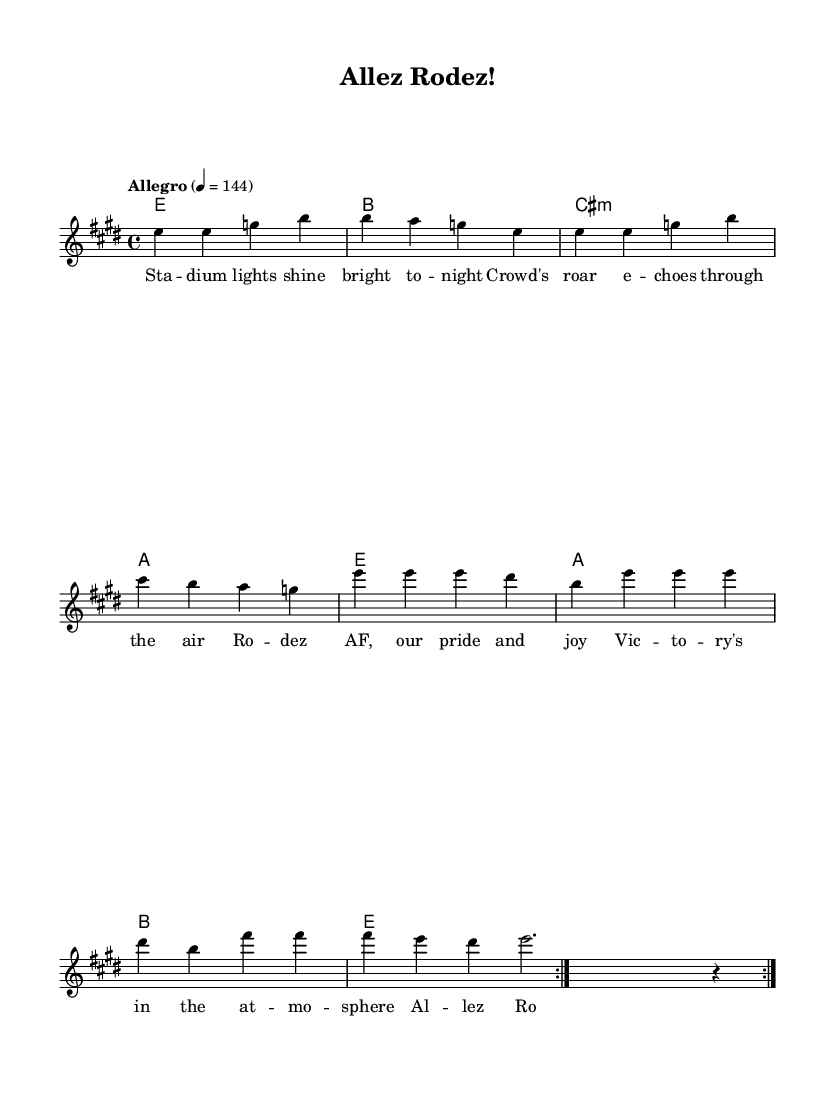What is the key signature of this music? The key signature indicates the key of E major, which has four sharps: F#, C#, G#, and D#. This is confirmed by the `\key e \major` directive present in the code.
Answer: E major What is the time signature of this music? The time signature is represented as 4/4, which means there are four beats in a measure and the quarter note receives one beat. This is directly stated in the code as `\time 4/4`.
Answer: 4/4 What is the tempo marking for this music? The tempo marking shows that the piece should be played at an Allegro speed, specifically indicating 144 beats per minute. This is indicated in the code with `\tempo "Allegro" 4 = 144`.
Answer: Allegro How many measures are in the melody section repeated? The melody section is marked to repeat two times as indicated by the `\repeat volta 2` notation surrounding the melody notes, which signifies the repetition of the measures within its scope.
Answer: 2 What is the title of the song? The title of the song is displayed in the header section of the code as `title = "Allez Rodez!"`, which signifies its identity.
Answer: Allez Rodez! What is the main theme of the lyrics? The lyrics focus on the experience and emotion surrounding a football match, specifically celebrating the team Rodez AF and the atmosphere of victory during matches. This is derived from the content of the provided lyrics.
Answer: Football pride How many chord changes occur in one complete cycle of the harmonies? There are four chord changes in one complete cycle of the harmonies as evident from the harmonic structure provided in the code, where each line specifies a chord for the harmony.
Answer: 4 